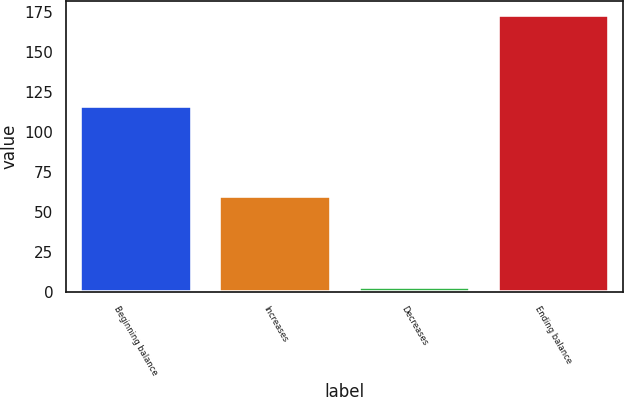Convert chart. <chart><loc_0><loc_0><loc_500><loc_500><bar_chart><fcel>Beginning balance<fcel>Increases<fcel>Decreases<fcel>Ending balance<nl><fcel>116<fcel>60<fcel>3<fcel>173<nl></chart> 